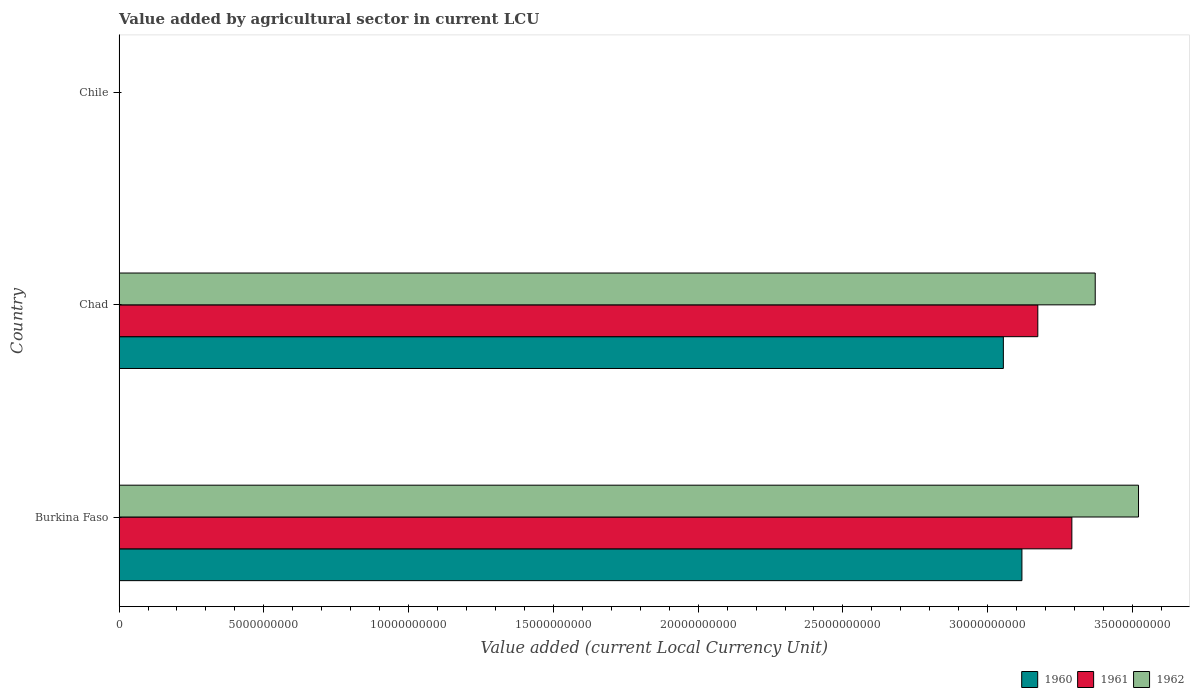How many groups of bars are there?
Offer a very short reply. 3. Are the number of bars per tick equal to the number of legend labels?
Provide a succinct answer. Yes. Are the number of bars on each tick of the Y-axis equal?
Your answer should be very brief. Yes. How many bars are there on the 3rd tick from the top?
Provide a short and direct response. 3. How many bars are there on the 2nd tick from the bottom?
Keep it short and to the point. 3. What is the label of the 3rd group of bars from the top?
Ensure brevity in your answer.  Burkina Faso. What is the value added by agricultural sector in 1960 in Burkina Faso?
Your answer should be very brief. 3.12e+1. Across all countries, what is the maximum value added by agricultural sector in 1962?
Your answer should be compact. 3.52e+1. Across all countries, what is the minimum value added by agricultural sector in 1960?
Offer a terse response. 4.00e+05. In which country was the value added by agricultural sector in 1961 maximum?
Your answer should be very brief. Burkina Faso. In which country was the value added by agricultural sector in 1960 minimum?
Provide a succinct answer. Chile. What is the total value added by agricultural sector in 1962 in the graph?
Make the answer very short. 6.89e+1. What is the difference between the value added by agricultural sector in 1961 in Burkina Faso and that in Chile?
Give a very brief answer. 3.29e+1. What is the difference between the value added by agricultural sector in 1962 in Burkina Faso and the value added by agricultural sector in 1961 in Chad?
Your answer should be compact. 3.48e+09. What is the average value added by agricultural sector in 1960 per country?
Make the answer very short. 2.06e+1. What is the difference between the value added by agricultural sector in 1962 and value added by agricultural sector in 1961 in Chad?
Offer a very short reply. 1.98e+09. What is the ratio of the value added by agricultural sector in 1960 in Burkina Faso to that in Chad?
Your answer should be very brief. 1.02. What is the difference between the highest and the second highest value added by agricultural sector in 1962?
Ensure brevity in your answer.  1.50e+09. What is the difference between the highest and the lowest value added by agricultural sector in 1962?
Ensure brevity in your answer.  3.52e+1. In how many countries, is the value added by agricultural sector in 1962 greater than the average value added by agricultural sector in 1962 taken over all countries?
Your response must be concise. 2. What does the 1st bar from the top in Burkina Faso represents?
Offer a terse response. 1962. What does the 3rd bar from the bottom in Chad represents?
Your answer should be very brief. 1962. Is it the case that in every country, the sum of the value added by agricultural sector in 1961 and value added by agricultural sector in 1962 is greater than the value added by agricultural sector in 1960?
Give a very brief answer. Yes. How many countries are there in the graph?
Provide a short and direct response. 3. Does the graph contain any zero values?
Make the answer very short. No. Does the graph contain grids?
Your answer should be very brief. No. Where does the legend appear in the graph?
Offer a terse response. Bottom right. What is the title of the graph?
Your response must be concise. Value added by agricultural sector in current LCU. Does "1963" appear as one of the legend labels in the graph?
Your answer should be very brief. No. What is the label or title of the X-axis?
Provide a short and direct response. Value added (current Local Currency Unit). What is the Value added (current Local Currency Unit) of 1960 in Burkina Faso?
Provide a succinct answer. 3.12e+1. What is the Value added (current Local Currency Unit) in 1961 in Burkina Faso?
Offer a very short reply. 3.29e+1. What is the Value added (current Local Currency Unit) of 1962 in Burkina Faso?
Keep it short and to the point. 3.52e+1. What is the Value added (current Local Currency Unit) of 1960 in Chad?
Your answer should be compact. 3.05e+1. What is the Value added (current Local Currency Unit) in 1961 in Chad?
Your response must be concise. 3.17e+1. What is the Value added (current Local Currency Unit) in 1962 in Chad?
Provide a succinct answer. 3.37e+1. What is the Value added (current Local Currency Unit) of 1962 in Chile?
Your response must be concise. 5.00e+05. Across all countries, what is the maximum Value added (current Local Currency Unit) of 1960?
Provide a succinct answer. 3.12e+1. Across all countries, what is the maximum Value added (current Local Currency Unit) of 1961?
Your answer should be very brief. 3.29e+1. Across all countries, what is the maximum Value added (current Local Currency Unit) in 1962?
Your answer should be compact. 3.52e+1. Across all countries, what is the minimum Value added (current Local Currency Unit) in 1960?
Your response must be concise. 4.00e+05. What is the total Value added (current Local Currency Unit) in 1960 in the graph?
Offer a very short reply. 6.17e+1. What is the total Value added (current Local Currency Unit) in 1961 in the graph?
Your response must be concise. 6.46e+1. What is the total Value added (current Local Currency Unit) of 1962 in the graph?
Provide a succinct answer. 6.89e+1. What is the difference between the Value added (current Local Currency Unit) in 1960 in Burkina Faso and that in Chad?
Offer a very short reply. 6.41e+08. What is the difference between the Value added (current Local Currency Unit) of 1961 in Burkina Faso and that in Chad?
Provide a short and direct response. 1.18e+09. What is the difference between the Value added (current Local Currency Unit) of 1962 in Burkina Faso and that in Chad?
Your answer should be compact. 1.50e+09. What is the difference between the Value added (current Local Currency Unit) in 1960 in Burkina Faso and that in Chile?
Offer a terse response. 3.12e+1. What is the difference between the Value added (current Local Currency Unit) of 1961 in Burkina Faso and that in Chile?
Provide a short and direct response. 3.29e+1. What is the difference between the Value added (current Local Currency Unit) in 1962 in Burkina Faso and that in Chile?
Keep it short and to the point. 3.52e+1. What is the difference between the Value added (current Local Currency Unit) of 1960 in Chad and that in Chile?
Your response must be concise. 3.05e+1. What is the difference between the Value added (current Local Currency Unit) of 1961 in Chad and that in Chile?
Offer a terse response. 3.17e+1. What is the difference between the Value added (current Local Currency Unit) of 1962 in Chad and that in Chile?
Provide a succinct answer. 3.37e+1. What is the difference between the Value added (current Local Currency Unit) of 1960 in Burkina Faso and the Value added (current Local Currency Unit) of 1961 in Chad?
Make the answer very short. -5.49e+08. What is the difference between the Value added (current Local Currency Unit) of 1960 in Burkina Faso and the Value added (current Local Currency Unit) of 1962 in Chad?
Keep it short and to the point. -2.53e+09. What is the difference between the Value added (current Local Currency Unit) of 1961 in Burkina Faso and the Value added (current Local Currency Unit) of 1962 in Chad?
Give a very brief answer. -8.07e+08. What is the difference between the Value added (current Local Currency Unit) in 1960 in Burkina Faso and the Value added (current Local Currency Unit) in 1961 in Chile?
Ensure brevity in your answer.  3.12e+1. What is the difference between the Value added (current Local Currency Unit) of 1960 in Burkina Faso and the Value added (current Local Currency Unit) of 1962 in Chile?
Offer a terse response. 3.12e+1. What is the difference between the Value added (current Local Currency Unit) of 1961 in Burkina Faso and the Value added (current Local Currency Unit) of 1962 in Chile?
Your answer should be compact. 3.29e+1. What is the difference between the Value added (current Local Currency Unit) in 1960 in Chad and the Value added (current Local Currency Unit) in 1961 in Chile?
Your answer should be compact. 3.05e+1. What is the difference between the Value added (current Local Currency Unit) in 1960 in Chad and the Value added (current Local Currency Unit) in 1962 in Chile?
Make the answer very short. 3.05e+1. What is the difference between the Value added (current Local Currency Unit) of 1961 in Chad and the Value added (current Local Currency Unit) of 1962 in Chile?
Offer a terse response. 3.17e+1. What is the average Value added (current Local Currency Unit) in 1960 per country?
Offer a terse response. 2.06e+1. What is the average Value added (current Local Currency Unit) in 1961 per country?
Your response must be concise. 2.15e+1. What is the average Value added (current Local Currency Unit) of 1962 per country?
Offer a very short reply. 2.30e+1. What is the difference between the Value added (current Local Currency Unit) in 1960 and Value added (current Local Currency Unit) in 1961 in Burkina Faso?
Keep it short and to the point. -1.73e+09. What is the difference between the Value added (current Local Currency Unit) of 1960 and Value added (current Local Currency Unit) of 1962 in Burkina Faso?
Ensure brevity in your answer.  -4.03e+09. What is the difference between the Value added (current Local Currency Unit) in 1961 and Value added (current Local Currency Unit) in 1962 in Burkina Faso?
Your answer should be compact. -2.30e+09. What is the difference between the Value added (current Local Currency Unit) in 1960 and Value added (current Local Currency Unit) in 1961 in Chad?
Your response must be concise. -1.19e+09. What is the difference between the Value added (current Local Currency Unit) of 1960 and Value added (current Local Currency Unit) of 1962 in Chad?
Your response must be concise. -3.17e+09. What is the difference between the Value added (current Local Currency Unit) in 1961 and Value added (current Local Currency Unit) in 1962 in Chad?
Give a very brief answer. -1.98e+09. What is the difference between the Value added (current Local Currency Unit) of 1960 and Value added (current Local Currency Unit) of 1961 in Chile?
Offer a terse response. -1.00e+05. What is the difference between the Value added (current Local Currency Unit) in 1960 and Value added (current Local Currency Unit) in 1962 in Chile?
Ensure brevity in your answer.  -1.00e+05. What is the ratio of the Value added (current Local Currency Unit) of 1961 in Burkina Faso to that in Chad?
Provide a succinct answer. 1.04. What is the ratio of the Value added (current Local Currency Unit) of 1962 in Burkina Faso to that in Chad?
Offer a very short reply. 1.04. What is the ratio of the Value added (current Local Currency Unit) in 1960 in Burkina Faso to that in Chile?
Keep it short and to the point. 7.80e+04. What is the ratio of the Value added (current Local Currency Unit) in 1961 in Burkina Faso to that in Chile?
Provide a short and direct response. 6.58e+04. What is the ratio of the Value added (current Local Currency Unit) in 1962 in Burkina Faso to that in Chile?
Give a very brief answer. 7.04e+04. What is the ratio of the Value added (current Local Currency Unit) in 1960 in Chad to that in Chile?
Ensure brevity in your answer.  7.64e+04. What is the ratio of the Value added (current Local Currency Unit) of 1961 in Chad to that in Chile?
Your answer should be compact. 6.35e+04. What is the ratio of the Value added (current Local Currency Unit) in 1962 in Chad to that in Chile?
Provide a succinct answer. 6.74e+04. What is the difference between the highest and the second highest Value added (current Local Currency Unit) of 1960?
Give a very brief answer. 6.41e+08. What is the difference between the highest and the second highest Value added (current Local Currency Unit) in 1961?
Keep it short and to the point. 1.18e+09. What is the difference between the highest and the second highest Value added (current Local Currency Unit) in 1962?
Ensure brevity in your answer.  1.50e+09. What is the difference between the highest and the lowest Value added (current Local Currency Unit) in 1960?
Your response must be concise. 3.12e+1. What is the difference between the highest and the lowest Value added (current Local Currency Unit) in 1961?
Make the answer very short. 3.29e+1. What is the difference between the highest and the lowest Value added (current Local Currency Unit) in 1962?
Make the answer very short. 3.52e+1. 